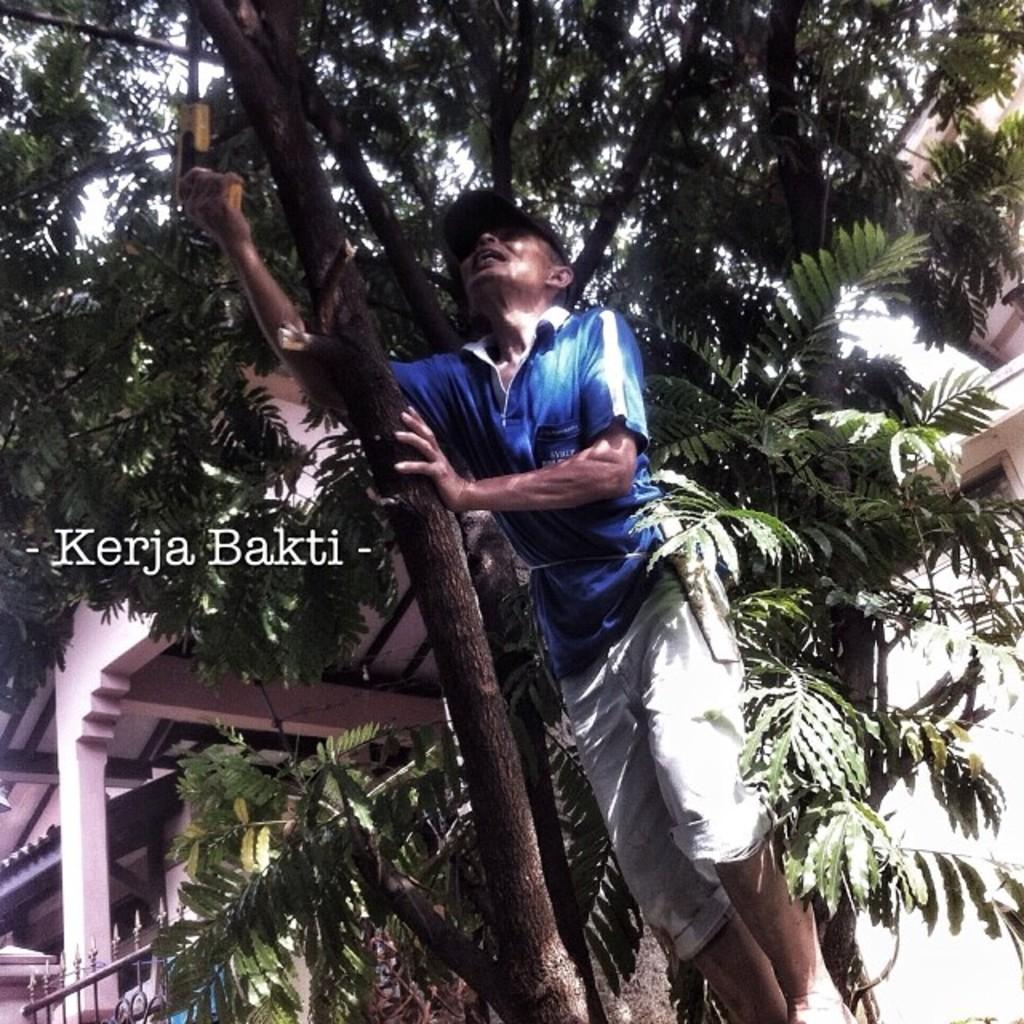What type of natural elements can be seen in the image? There are trees in the image. What type of man-made structures are present in the image? There are buildings in the image. What is the man in the image holding? The man is holding a tree branch and an instrument in his hand. Where can text be found in the image? The text is on the left side of the image. What type of eggnog is being served in the image? There is no eggnog present in the image. What type of ray is visible in the image? There is no ray visible in the image. 